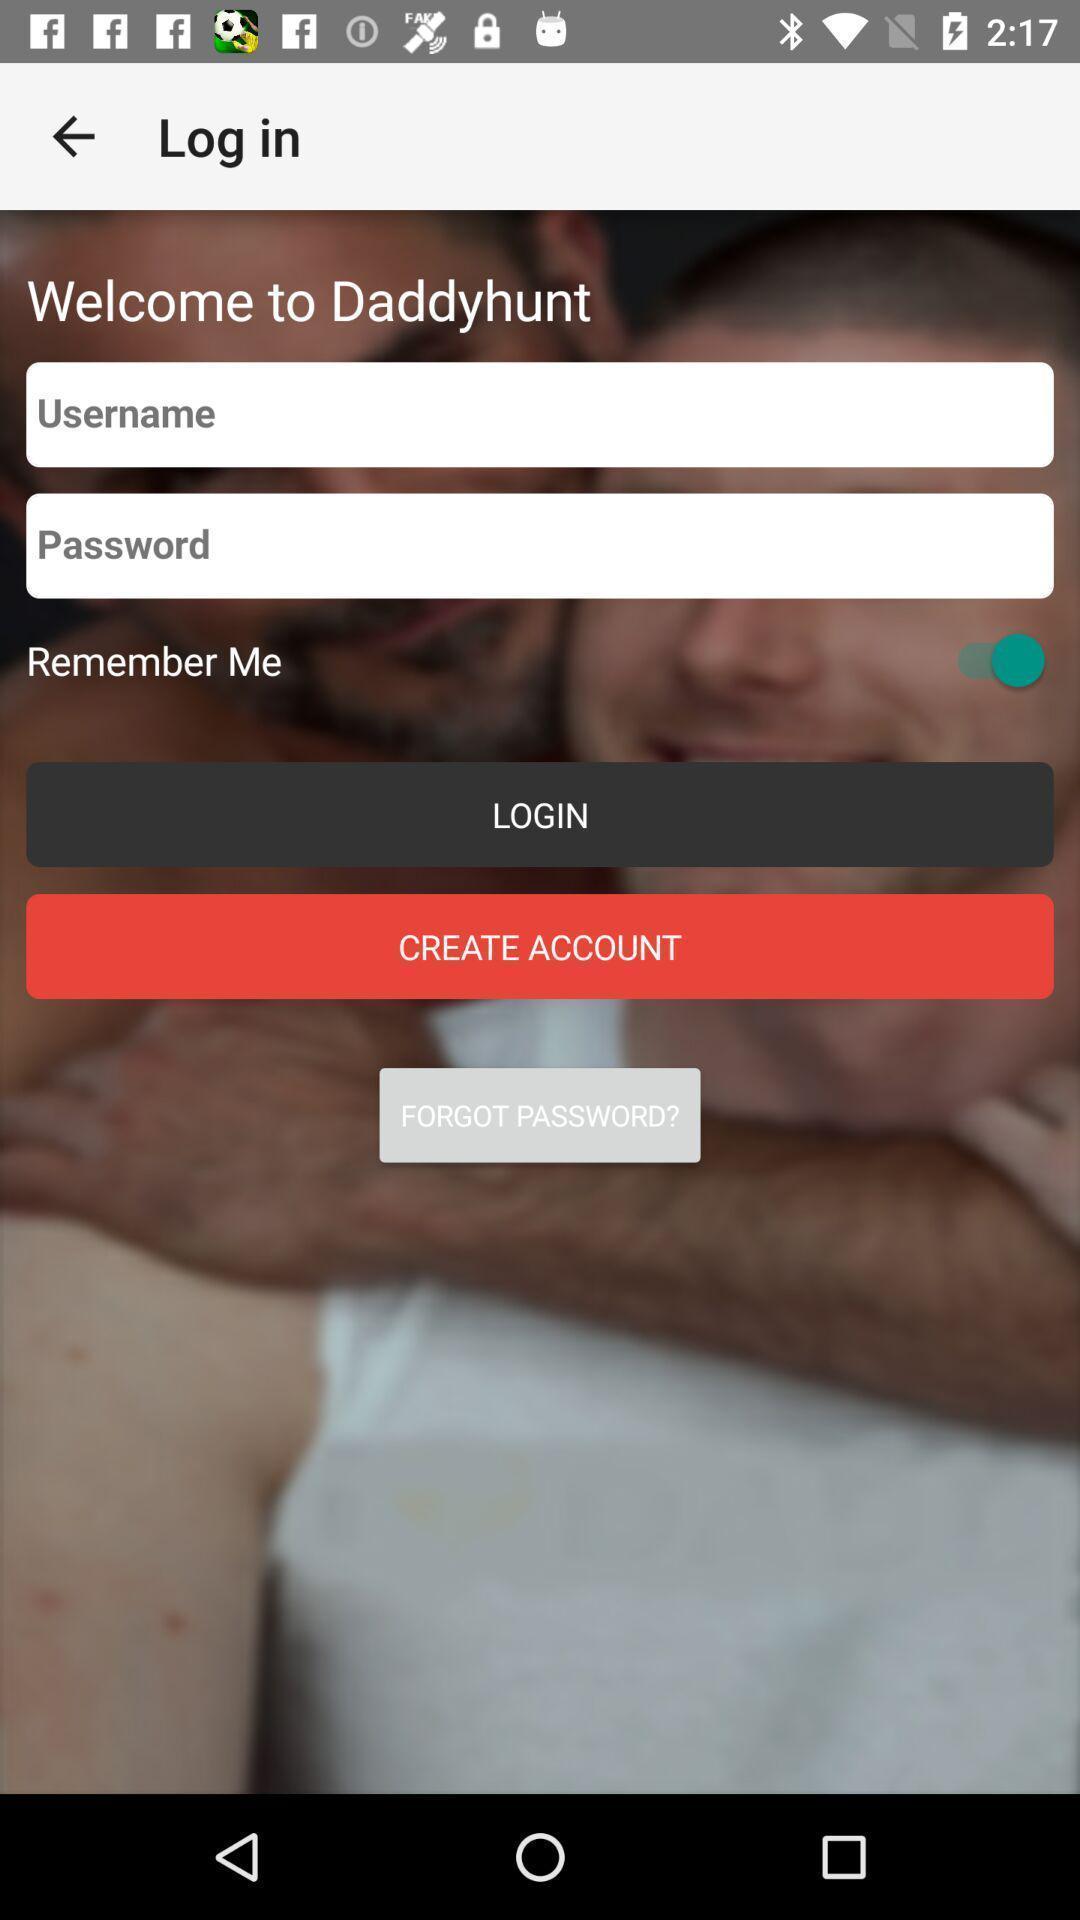Summarize the information in this screenshot. Welcome page of a social application. 